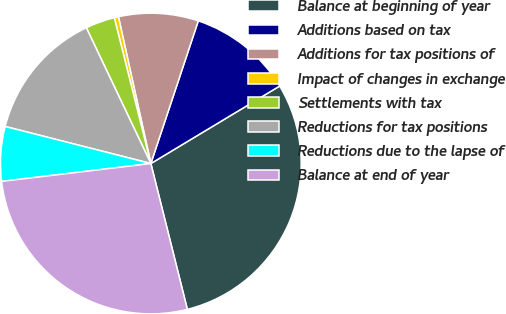Convert chart to OTSL. <chart><loc_0><loc_0><loc_500><loc_500><pie_chart><fcel>Balance at beginning of year<fcel>Additions based on tax<fcel>Additions for tax positions of<fcel>Impact of changes in exchange<fcel>Settlements with tax<fcel>Reductions for tax positions<fcel>Reductions due to the lapse of<fcel>Balance at end of year<nl><fcel>29.72%<fcel>11.27%<fcel>8.57%<fcel>0.45%<fcel>3.15%<fcel>13.98%<fcel>5.86%<fcel>27.01%<nl></chart> 